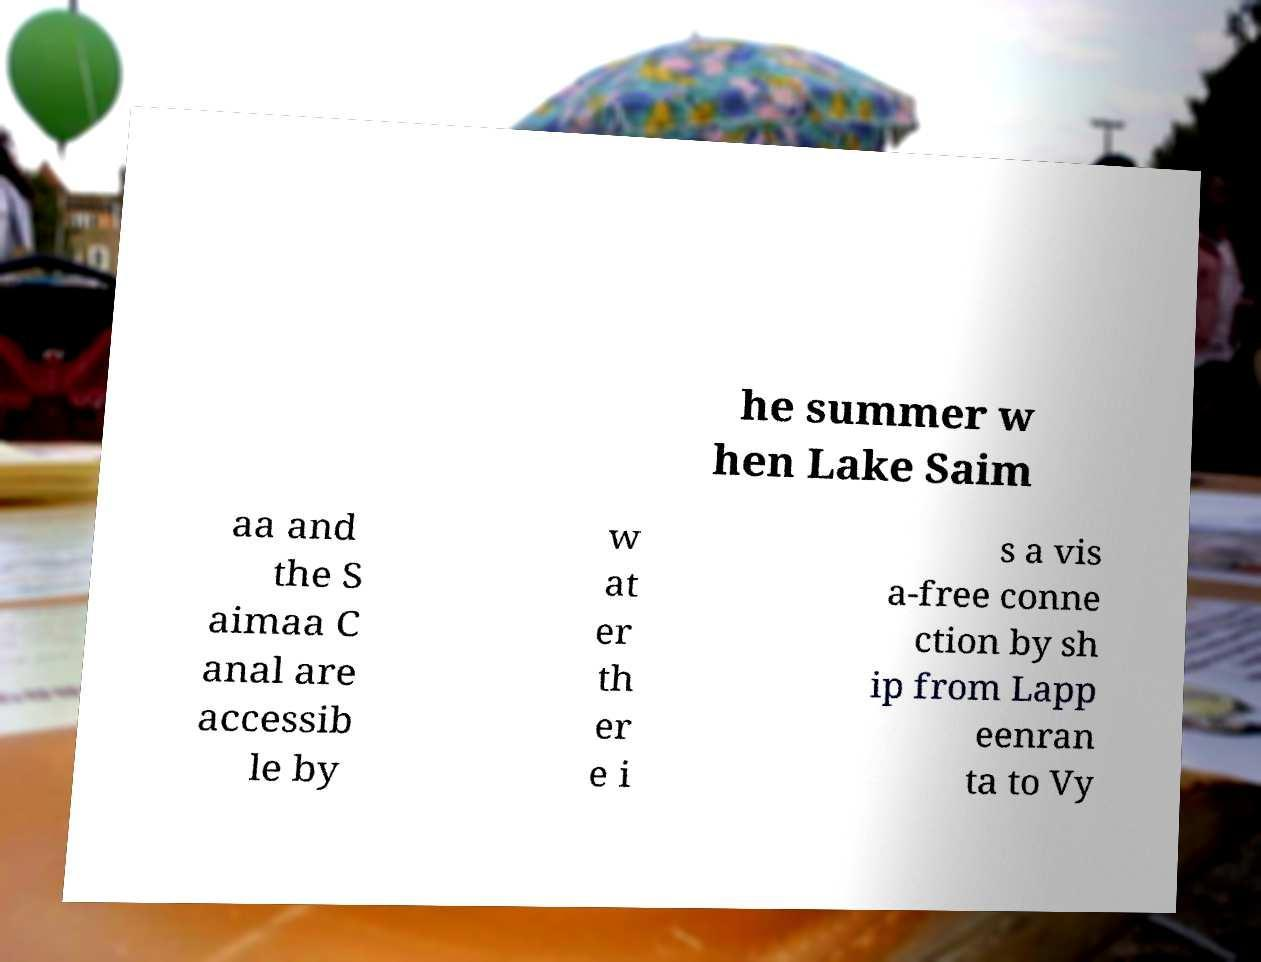For documentation purposes, I need the text within this image transcribed. Could you provide that? he summer w hen Lake Saim aa and the S aimaa C anal are accessib le by w at er th er e i s a vis a-free conne ction by sh ip from Lapp eenran ta to Vy 